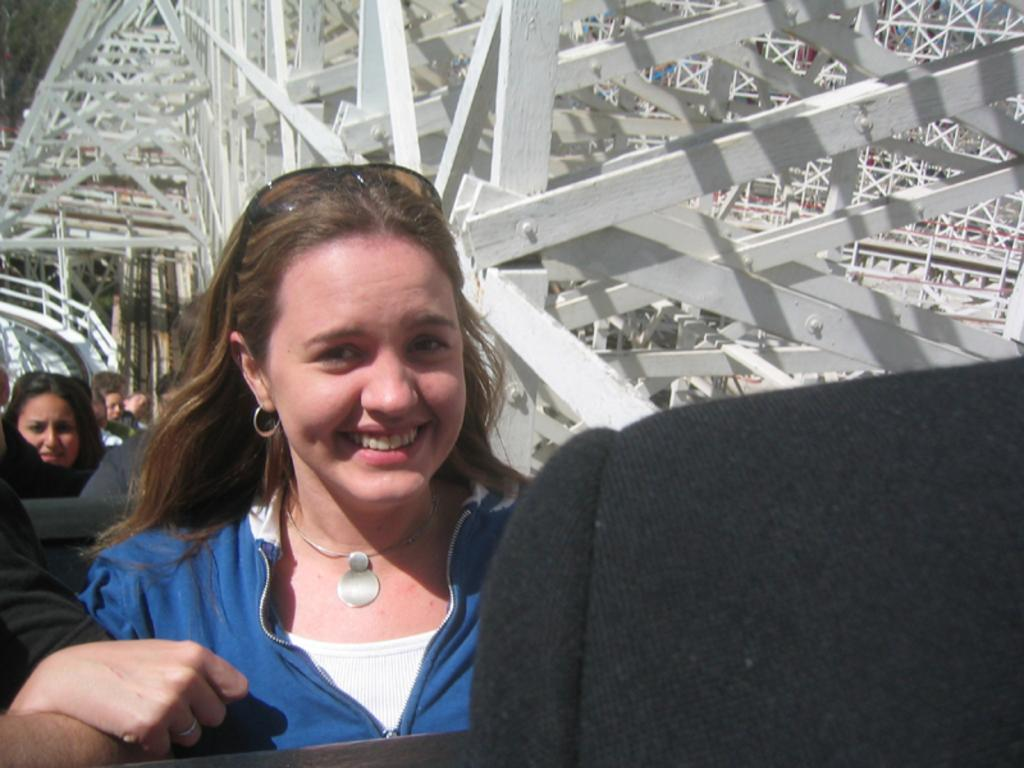What are the people in the image doing? The people in the image are sitting in the seats. What material is used for the frames of the seats? The frames of the seats are made of metal. Can you see any grapes hanging from the metal frames in the image? There are no grapes present in the image; the metal frames are part of the seats. Is there a tent visible in the image? There is no tent present in the image. 